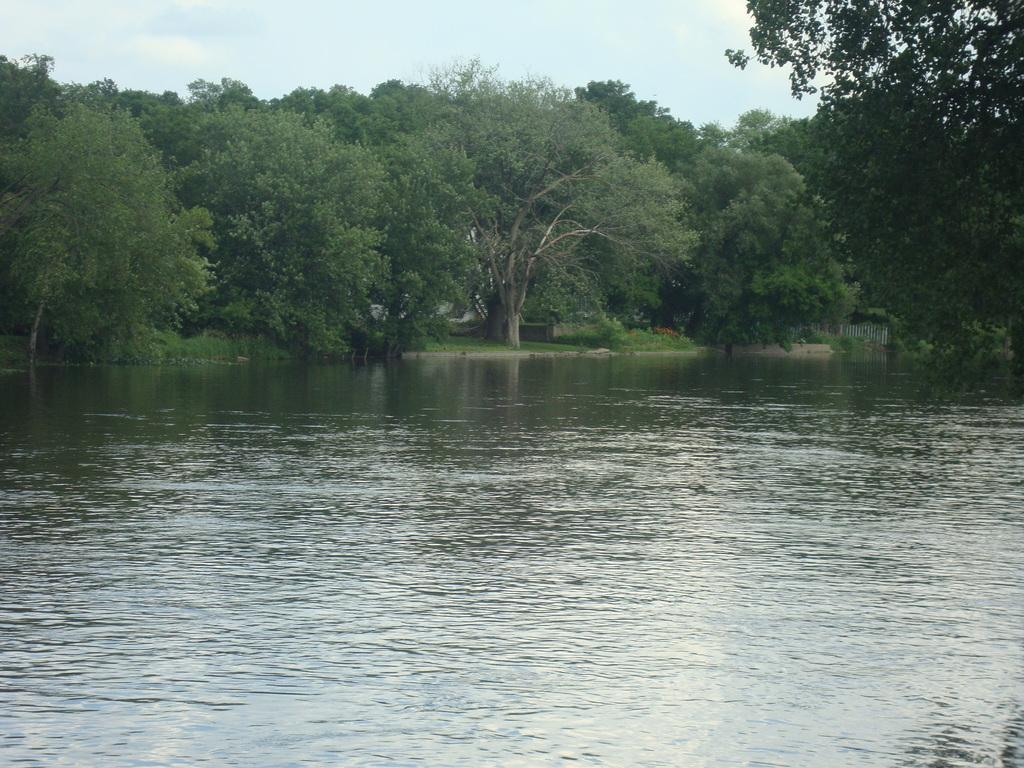What is located in the middle of the image? There is water in the middle of the image. What can be seen in the background of the image? There are trees in the background of the image. What is visible at the top of the image? The sky is visible at the top of the image. What type of development can be seen in the image? There is no development or construction visible in the image; it primarily features water, trees, and the sky. How does the club appear in the image? There is no club present in the image. 